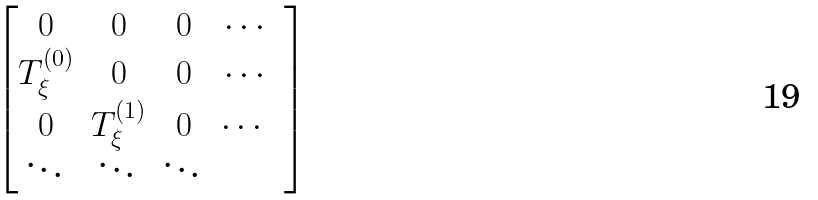Convert formula to latex. <formula><loc_0><loc_0><loc_500><loc_500>\begin{bmatrix} 0 & 0 & 0 & \cdots \\ T _ { \xi } ^ { ( 0 ) } & 0 & 0 & \cdots \\ 0 & T _ { \xi } ^ { ( 1 ) } & 0 & \cdots & \\ \ddots & \ddots & \ddots & \end{bmatrix}</formula> 